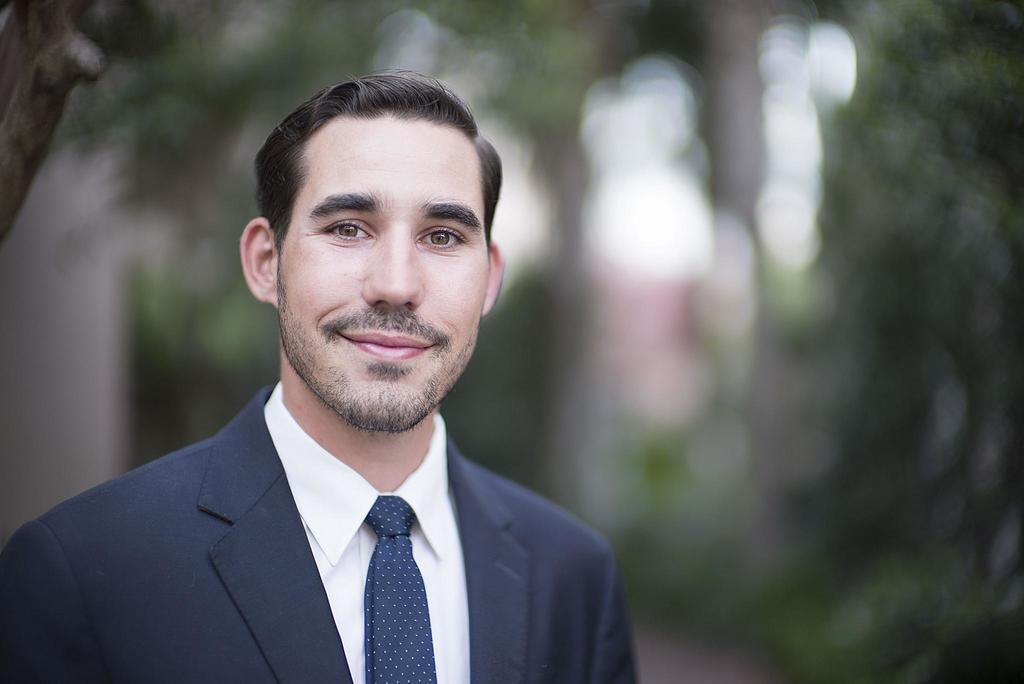What is partially visible in the image towards the bottom? There is a person truncated towards the bottom of the image. What is partially visible in the image towards the left? There is an object truncated towards the left of the image. How would you describe the background of the image? The background of the image is blurred. Where is the faucet located in the image? There is no faucet present in the image. Is there a baseball game happening in the image? There is no indication of a baseball game or any baseball-related objects in the image. 